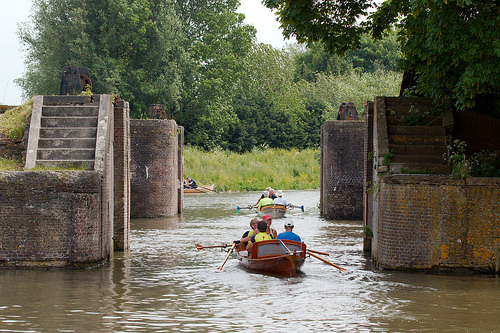<image>
Is there a man under the man? No. The man is not positioned under the man. The vertical relationship between these objects is different. Is there a oar above the water? No. The oar is not positioned above the water. The vertical arrangement shows a different relationship. 